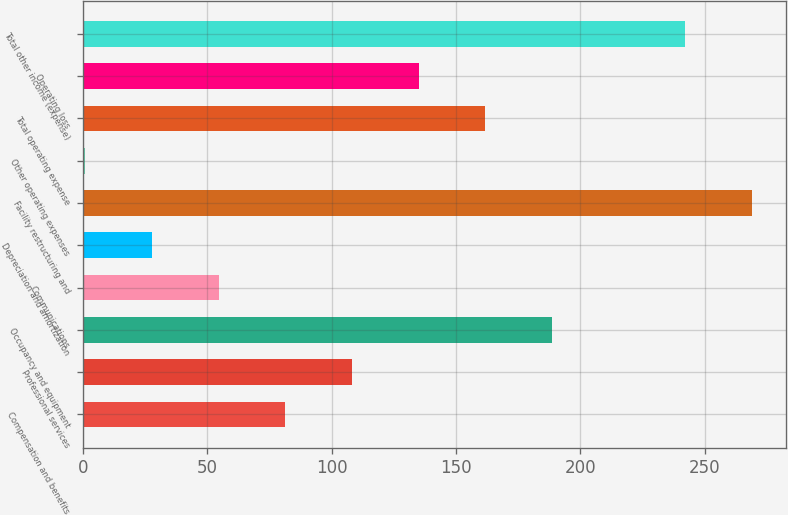<chart> <loc_0><loc_0><loc_500><loc_500><bar_chart><fcel>Compensation and benefits<fcel>Professional services<fcel>Occupancy and equipment<fcel>Communications<fcel>Depreciation and amortization<fcel>Facility restructuring and<fcel>Other operating expenses<fcel>Total operating expense<fcel>Operating loss<fcel>Total other income (expense)<nl><fcel>81.4<fcel>108.2<fcel>188.6<fcel>54.6<fcel>27.8<fcel>269<fcel>1<fcel>161.8<fcel>135<fcel>242.2<nl></chart> 